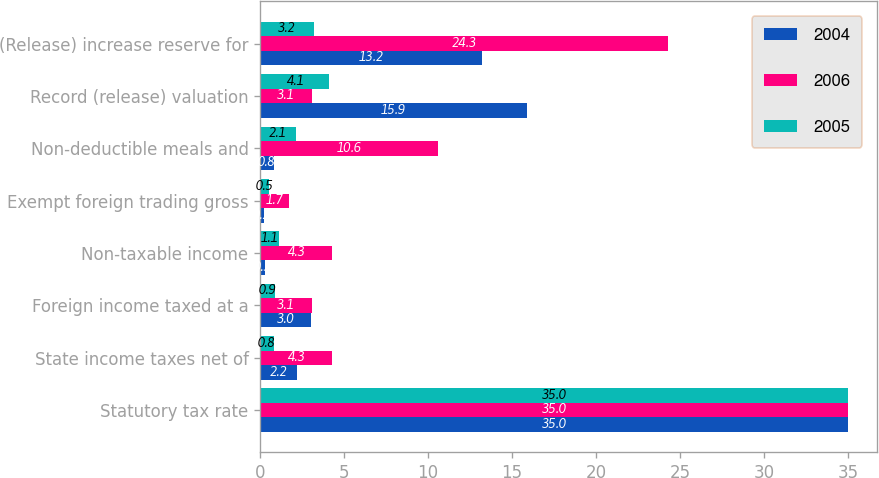Convert chart to OTSL. <chart><loc_0><loc_0><loc_500><loc_500><stacked_bar_chart><ecel><fcel>Statutory tax rate<fcel>State income taxes net of<fcel>Foreign income taxed at a<fcel>Non-taxable income<fcel>Exempt foreign trading gross<fcel>Non-deductible meals and<fcel>Record (release) valuation<fcel>(Release) increase reserve for<nl><fcel>2004<fcel>35<fcel>2.2<fcel>3<fcel>0.3<fcel>0.2<fcel>0.8<fcel>15.9<fcel>13.2<nl><fcel>2006<fcel>35<fcel>4.3<fcel>3.1<fcel>4.3<fcel>1.7<fcel>10.6<fcel>3.1<fcel>24.3<nl><fcel>2005<fcel>35<fcel>0.8<fcel>0.9<fcel>1.1<fcel>0.5<fcel>2.1<fcel>4.1<fcel>3.2<nl></chart> 